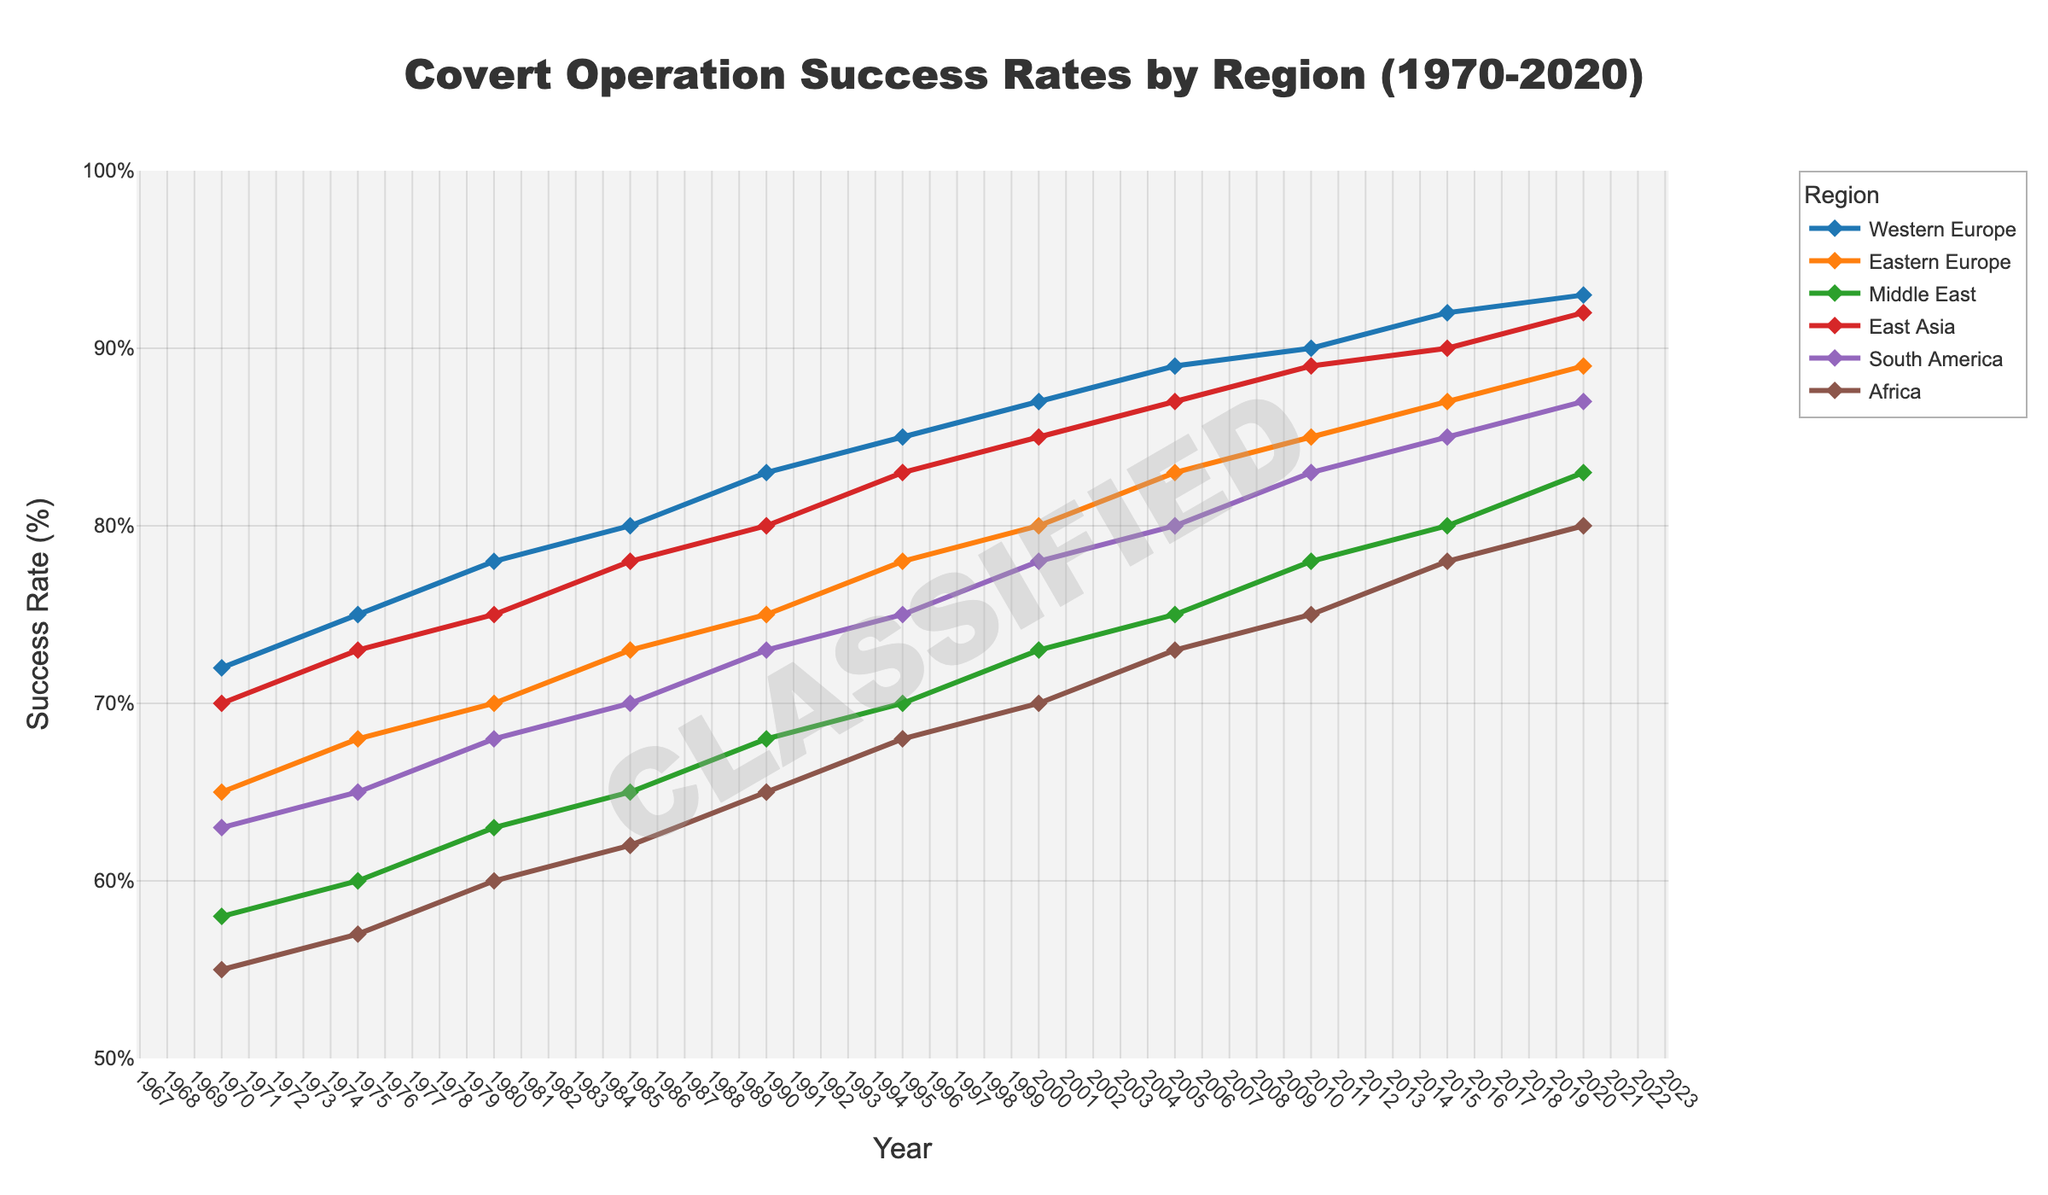What is the overall trend in covert operation success rates for Western Europe from 1970 to 2020? Look at the line representing Western Europe. It starts at 72% in 1970 and steadily rises to 93% in 2020, indicating a consistent upward trend.
Answer: Consistent upward trend Which region had the highest covert operation success rate in 2020? Compare the success rates of all the regions in 2020. Western Europe has the highest value at 93%.
Answer: Western Europe What is the average success rate for the Middle East between 1970 and 2020? Sum the yearly success rates for the Middle East and divide by the number of years: (58 + 60 + 63 + 65 + 68 + 70 + 73 + 75 + 78 + 80 + 83) / 11 = 695 / 11.
Answer: 63.18% How do the success rates of Africa and East Asia in 2015 compare? Look at the values for Africa and East Asia in 2015. Africa has 78% and East Asia has 90%.
Answer: Africa is lower by 12% By how much did the success rate for South America increase from 1970 to 2020? Subtract South America’s 1970 rate from the 2020 rate: 87% - 63% = 24%.
Answer: 24% Which region had the lowest success rate in 1970? Compare the success rates of all the regions in 1970. Africa has the lowest value at 55%.
Answer: Africa What is the increase in success rate for Eastern Europe from 1980 to 2010? Subtract Eastern Europe’s 1980 rate from the 2010 rate: 85% - 70% = 15%.
Answer: 15% In which decade did the Middle East see the highest increase in success rate? Calculate the increase in each decade: 
1970-1980: 63-58 = 5% 
1980-1990: 68-63 = 5% 
1990-2000: 73-68 = 5% 
2000-2010: 78-73 = 5% 
2010-2020: 83-78 = 5%. 
Each decade had a 5% increase, so it’s consistent.
Answer: Consistent across decades Which region showed the greatest variability in success rate from 1970 to 2020? Calculate the range (difference between highest and lowest) for each region: 
Western Europe: 93-72 = 21% 
Eastern Europe: 89-65 = 24% 
Middle East: 83-58 = 25% 
East Asia: 90-70 = 20% 
South America: 87-63 = 24% 
Africa: 80-55 = 25%. 
Middle East and Africa both show the greatest variability.
Answer: Middle East & Africa By how much did the success rates for Western Europe exceed those of Africa in 2020? Subtract Africa’s success rate from Western Europe’s in 2020: 93% - 80% = 13%.
Answer: 13% 